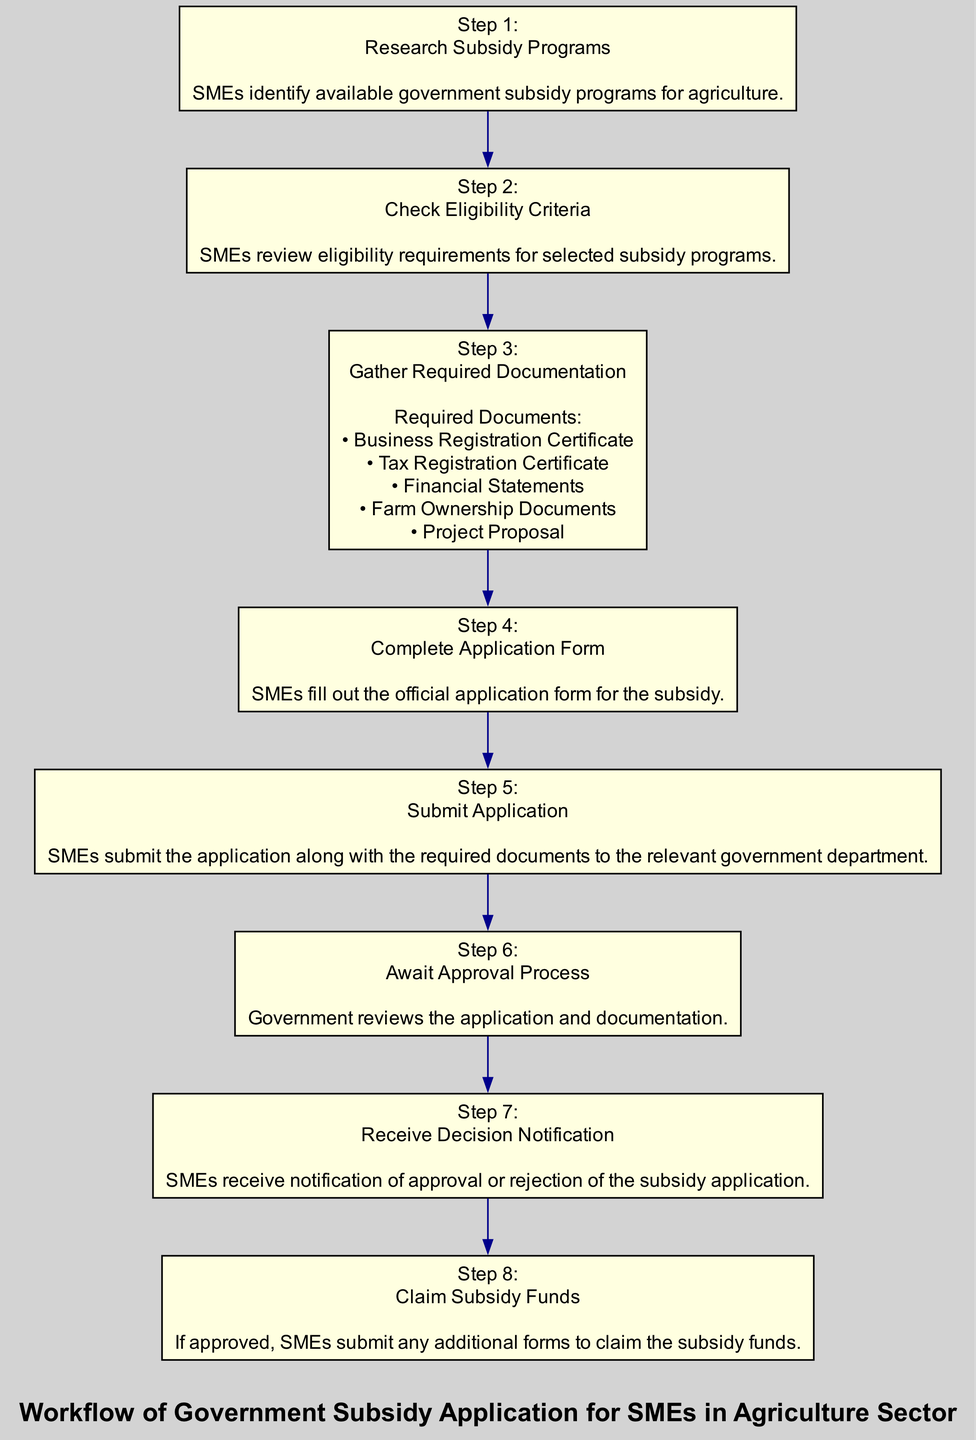What is the first step in the subsidy application workflow? The first step listed in the workflow is "Research Subsidy Programs," where SMEs identify available government subsidy programs for agriculture.
Answer: Research Subsidy Programs How many required documents are listed for gathering? There are five required documents listed in step 3, which include Business Registration Certificate, Tax Registration Certificate, Financial Statements, Farm Ownership Documents, and Project Proposal.
Answer: 5 Which step follows the submission of the application? After submitting the application in step 5, the next step is step 6, which is "Await Approval Process," where the government reviews the application and documentation.
Answer: Await Approval Process What action is taken if the application is approved? If the application is approved, SMEs will "Claim Subsidy Funds" in step 8, where they submit any additional forms to claim the subsidy funds.
Answer: Claim Subsidy Funds What documents are required to be gathered in step 3? The documents required in step 3 include Business Registration Certificate, Tax Registration Certificate, Financial Statements, Farm Ownership Documents, and Project Proposal.
Answer: Business Registration Certificate, Tax Registration Certificate, Financial Statements, Farm Ownership Documents, Project Proposal What is the last step in the subsidy application process? The last step in the process is step 8, which is "Claim Subsidy Funds." This indicates the completion of the application’s journey, assuming approval has been granted.
Answer: Claim Subsidy Funds What is the relationship between steps 4 and 5? Step 4 "Complete Application Form" directly precedes step 5 "Submit Application," indicating that filling out the application form must be completed before the application can be submitted.
Answer: Complete Application Form → Submit Application How does the workflow begin? The workflow begins with step 1 "Research Subsidy Programs," where SMEs start the process by identifying available subsidy programs.
Answer: Research Subsidy Programs 